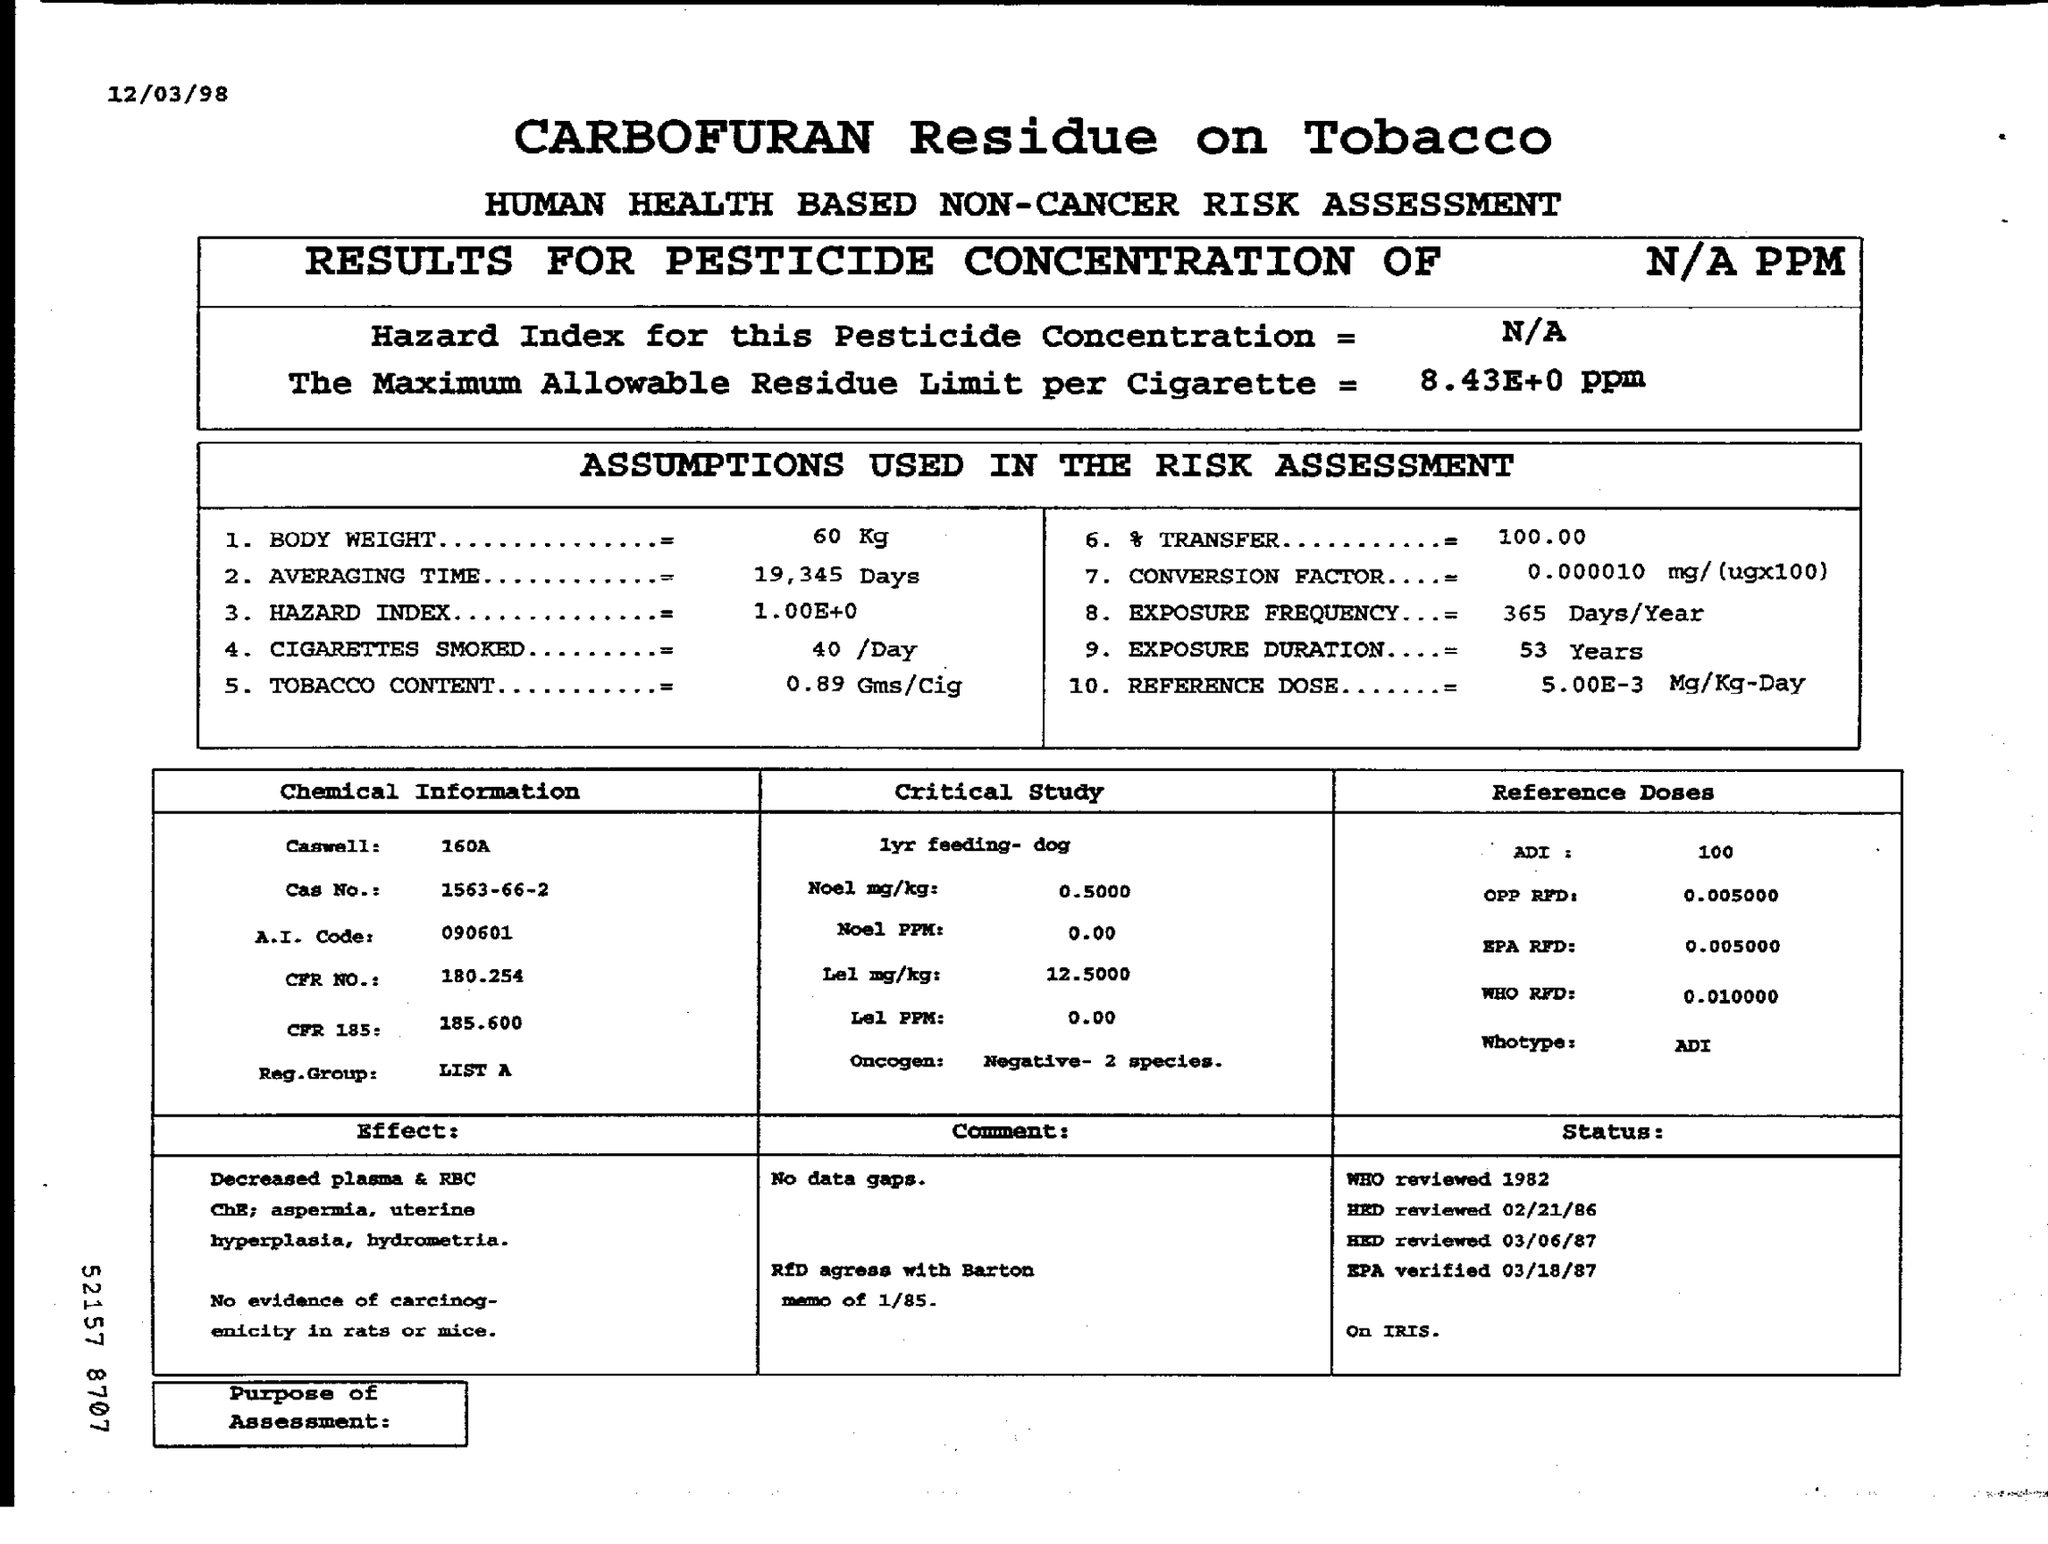What is the Hazard Index for this Pesticide Concentration? The Hazard Index for the pesticide concentration is listed as 1.004±0. The document appears to be a health-based non-cancer risk assessment for Carbofuran residue on tobacco, presenting various assumptions used in the risk assessment, chemical information, and reference doses for toxicity studies. 